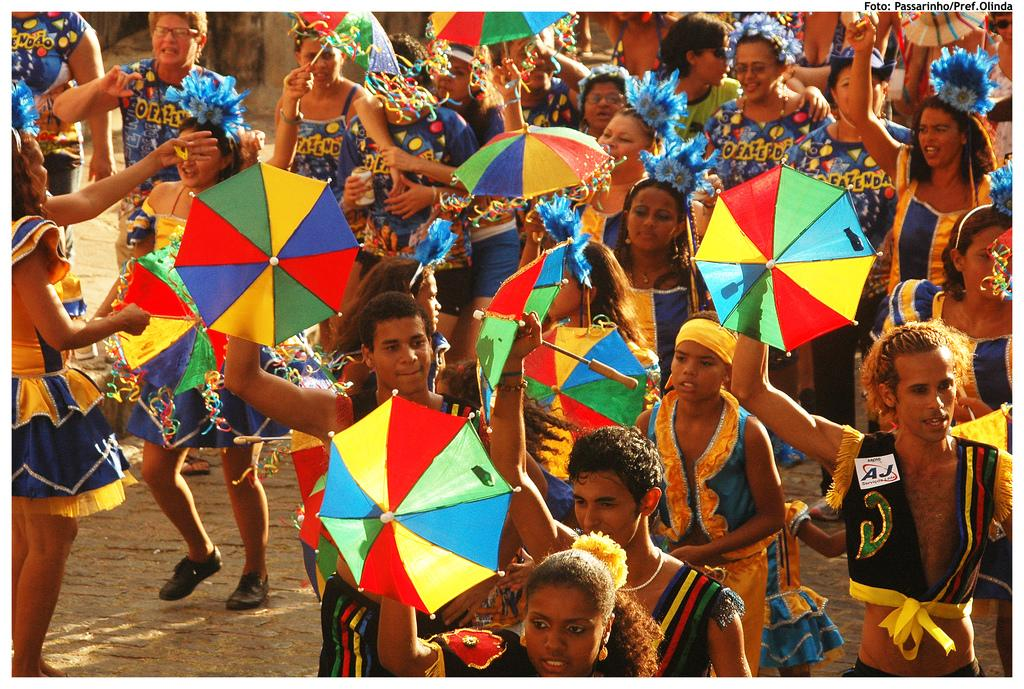<image>
Offer a succinct explanation of the picture presented. a person with AJ on their body and many people partying 